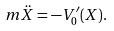<formula> <loc_0><loc_0><loc_500><loc_500>m \ddot { X } = - V _ { 0 } ^ { \prime } ( X ) .</formula> 